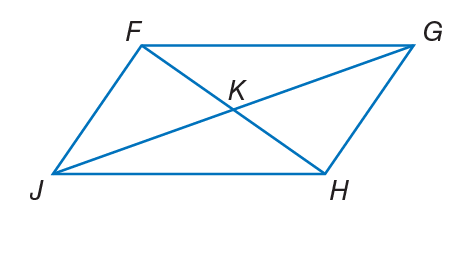Answer the mathemtical geometry problem and directly provide the correct option letter.
Question: If F K = 3 x - 1, K G = 4 y + 3, J K = 6 y - 2, and K H = 2 x + 3, find x so that the quadrilateral is a parallelogram.
Choices: A: 4 B: 5 C: 10 D: 12 A 